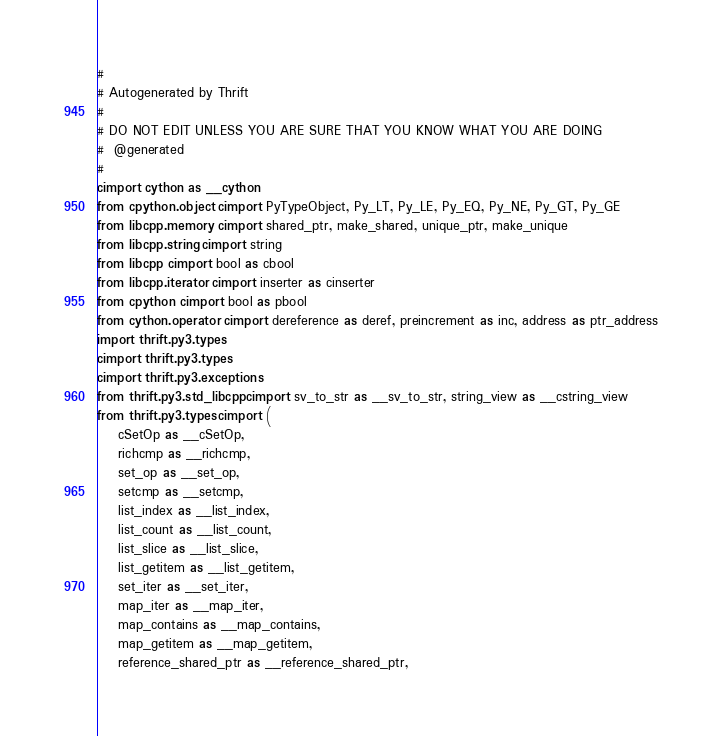Convert code to text. <code><loc_0><loc_0><loc_500><loc_500><_Cython_>#
# Autogenerated by Thrift
#
# DO NOT EDIT UNLESS YOU ARE SURE THAT YOU KNOW WHAT YOU ARE DOING
#  @generated
#
cimport cython as __cython
from cpython.object cimport PyTypeObject, Py_LT, Py_LE, Py_EQ, Py_NE, Py_GT, Py_GE
from libcpp.memory cimport shared_ptr, make_shared, unique_ptr, make_unique
from libcpp.string cimport string
from libcpp cimport bool as cbool
from libcpp.iterator cimport inserter as cinserter
from cpython cimport bool as pbool
from cython.operator cimport dereference as deref, preincrement as inc, address as ptr_address
import thrift.py3.types
cimport thrift.py3.types
cimport thrift.py3.exceptions
from thrift.py3.std_libcpp cimport sv_to_str as __sv_to_str, string_view as __cstring_view
from thrift.py3.types cimport (
    cSetOp as __cSetOp,
    richcmp as __richcmp,
    set_op as __set_op,
    setcmp as __setcmp,
    list_index as __list_index,
    list_count as __list_count,
    list_slice as __list_slice,
    list_getitem as __list_getitem,
    set_iter as __set_iter,
    map_iter as __map_iter,
    map_contains as __map_contains,
    map_getitem as __map_getitem,
    reference_shared_ptr as __reference_shared_ptr,</code> 